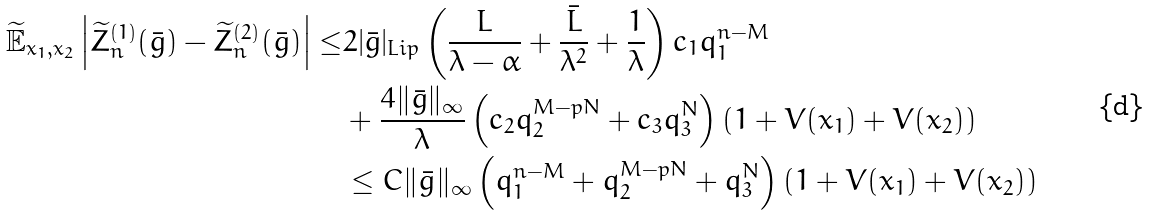<formula> <loc_0><loc_0><loc_500><loc_500>\widetilde { \mathbb { E } } _ { x _ { 1 } , x _ { 2 } } \left | \widetilde { Z } _ { n } ^ { ( 1 ) } ( \bar { g } ) - \widetilde { Z } _ { n } ^ { ( 2 ) } ( \bar { g } ) \right | \leq & 2 | \bar { g } | _ { L i p } \left ( \frac { L } { \lambda - \alpha } + \frac { \bar { L } } { \lambda ^ { 2 } } + \frac { 1 } { \lambda } \right ) c _ { 1 } q _ { 1 } ^ { n - M } \\ & + \frac { 4 \| \bar { g } \| _ { \infty } } { \lambda } \left ( c _ { 2 } q _ { 2 } ^ { M - p N } + c _ { 3 } q _ { 3 } ^ { N } \right ) \left ( 1 + V ( x _ { 1 } ) + V ( x _ { 2 } ) \right ) \\ & \leq C \| \bar { g } \| _ { \infty } \left ( q _ { 1 } ^ { n - M } + q _ { 2 } ^ { M - p N } + q _ { 3 } ^ { N } \right ) \left ( 1 + V ( x _ { 1 } ) + V ( x _ { 2 } ) \right )</formula> 